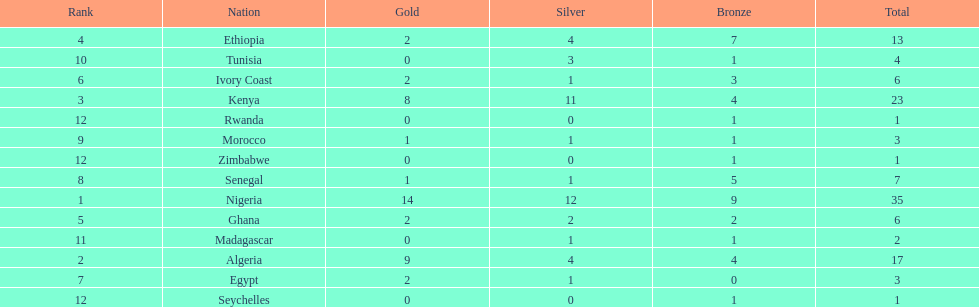The country that won the most medals was? Nigeria. 